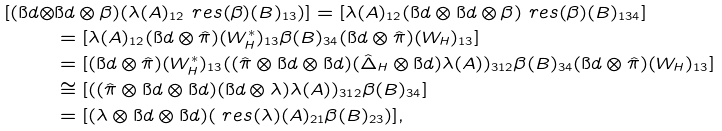Convert formula to latex. <formula><loc_0><loc_0><loc_500><loc_500>[ ( \i d \otimes & \i d \otimes \beta ) ( \lambda ( A ) _ { 1 2 } \ r e s ( \beta ) ( B ) _ { 1 3 } ) ] = [ \lambda ( A ) _ { 1 2 } ( \i d \otimes \i d \otimes \beta ) \ r e s ( \beta ) ( B ) _ { 1 3 4 } ] \\ & = [ \lambda ( A ) _ { 1 2 } ( \i d \otimes \hat { \pi } ) ( W _ { H } ^ { * } ) _ { 1 3 } \beta ( B ) _ { 3 4 } ( \i d \otimes \hat { \pi } ) ( W _ { H } ) _ { 1 3 } ] \\ & = [ ( \i d \otimes \hat { \pi } ) ( W _ { H } ^ { * } ) _ { 1 3 } ( ( \hat { \pi } \otimes \i d \otimes \i d ) ( \hat { \Delta } _ { H } \otimes \i d ) \lambda ( A ) ) _ { 3 1 2 } \beta ( B ) _ { 3 4 } ( \i d \otimes \hat { \pi } ) ( W _ { H } ) _ { 1 3 } ] \\ & \cong [ ( ( \hat { \pi } \otimes \i d \otimes \i d ) ( \i d \otimes \lambda ) \lambda ( A ) ) _ { 3 1 2 } \beta ( B ) _ { 3 4 } ] \\ & = [ ( \lambda \otimes \i d \otimes \i d ) ( \ r e s ( \lambda ) ( A ) _ { 2 1 } \beta ( B ) _ { 2 3 } ) ] ,</formula> 